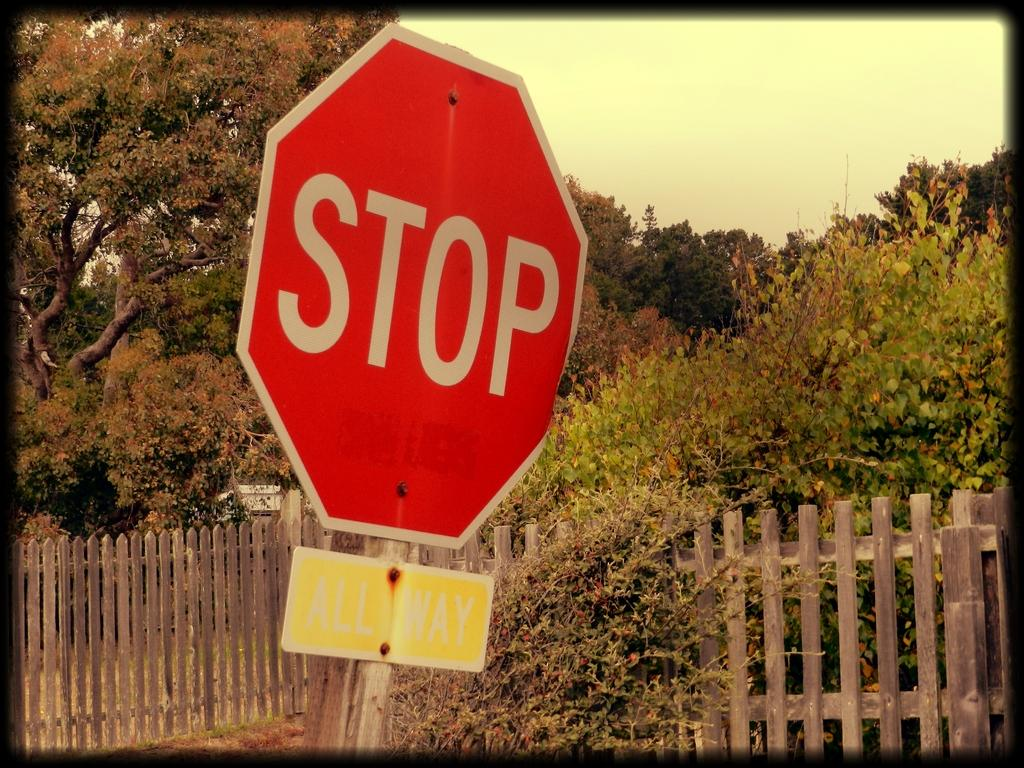<image>
Share a concise interpretation of the image provided. A red Stop sign slanted on a street side with yellow sign bellow beside a wood fence and a green trees with shrubs 